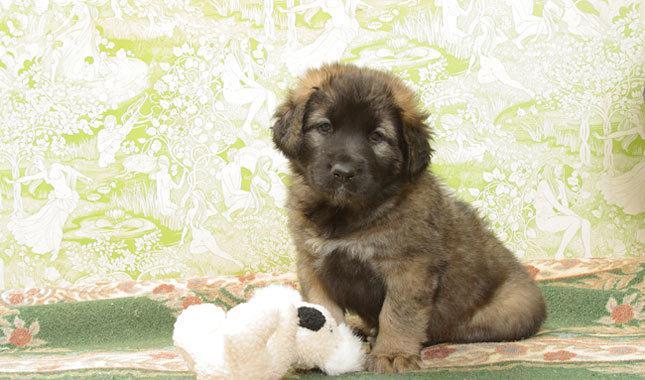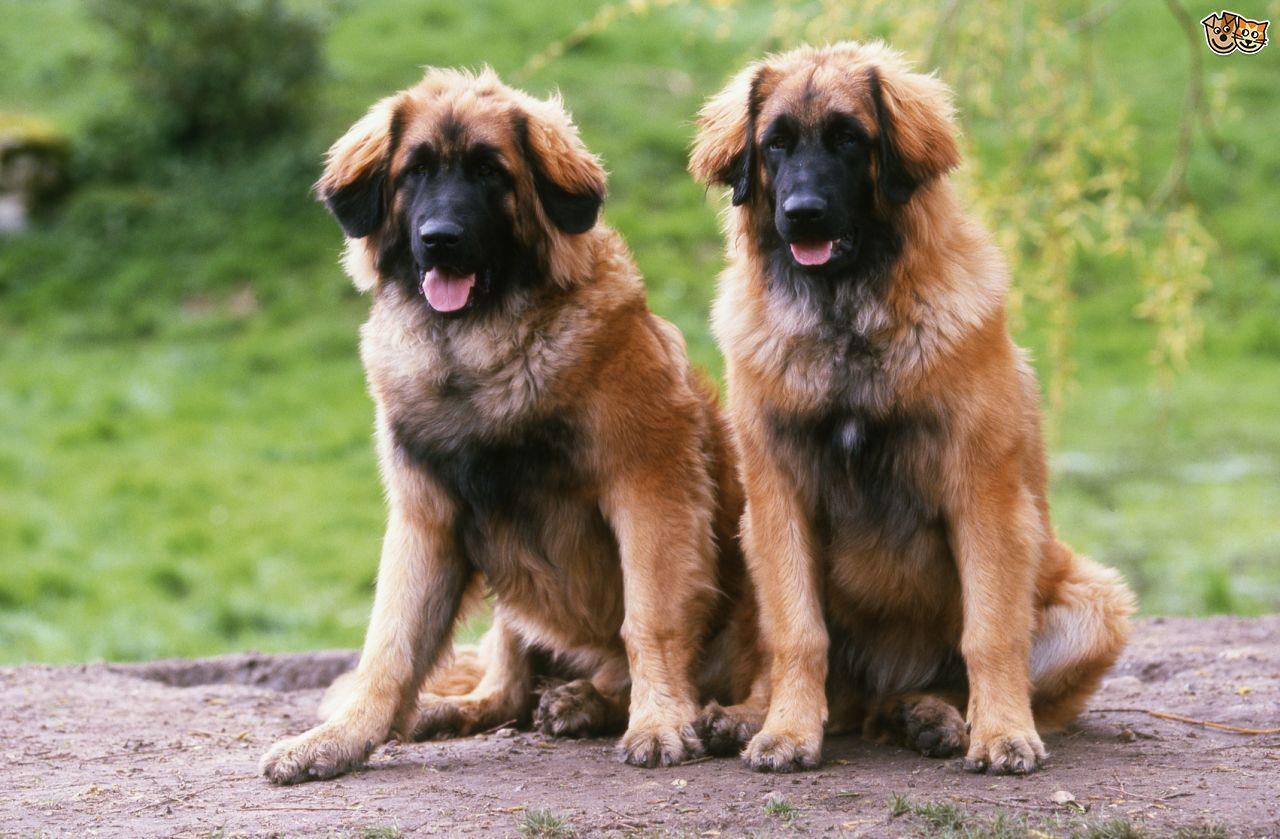The first image is the image on the left, the second image is the image on the right. Examine the images to the left and right. Is the description "there is a human standing with a dog." accurate? Answer yes or no. No. 